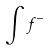Convert formula to latex. <formula><loc_0><loc_0><loc_500><loc_500>\int f ^ { - }</formula> 